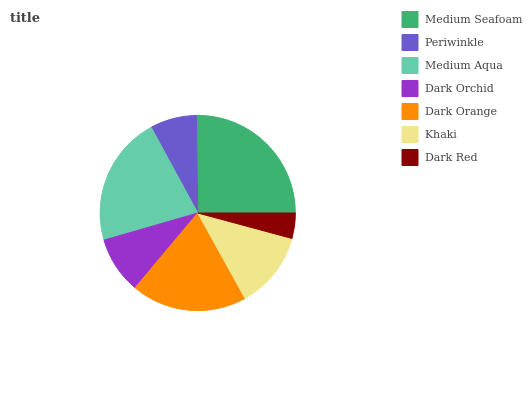Is Dark Red the minimum?
Answer yes or no. Yes. Is Medium Seafoam the maximum?
Answer yes or no. Yes. Is Periwinkle the minimum?
Answer yes or no. No. Is Periwinkle the maximum?
Answer yes or no. No. Is Medium Seafoam greater than Periwinkle?
Answer yes or no. Yes. Is Periwinkle less than Medium Seafoam?
Answer yes or no. Yes. Is Periwinkle greater than Medium Seafoam?
Answer yes or no. No. Is Medium Seafoam less than Periwinkle?
Answer yes or no. No. Is Khaki the high median?
Answer yes or no. Yes. Is Khaki the low median?
Answer yes or no. Yes. Is Dark Orchid the high median?
Answer yes or no. No. Is Medium Seafoam the low median?
Answer yes or no. No. 